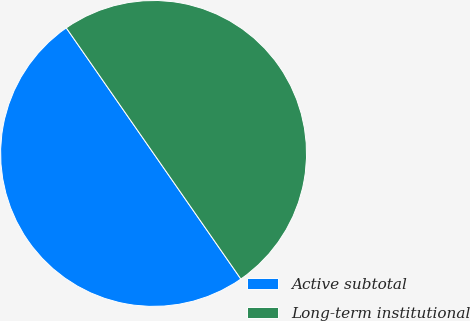Convert chart to OTSL. <chart><loc_0><loc_0><loc_500><loc_500><pie_chart><fcel>Active subtotal<fcel>Long-term institutional<nl><fcel>50.0%<fcel>50.0%<nl></chart> 